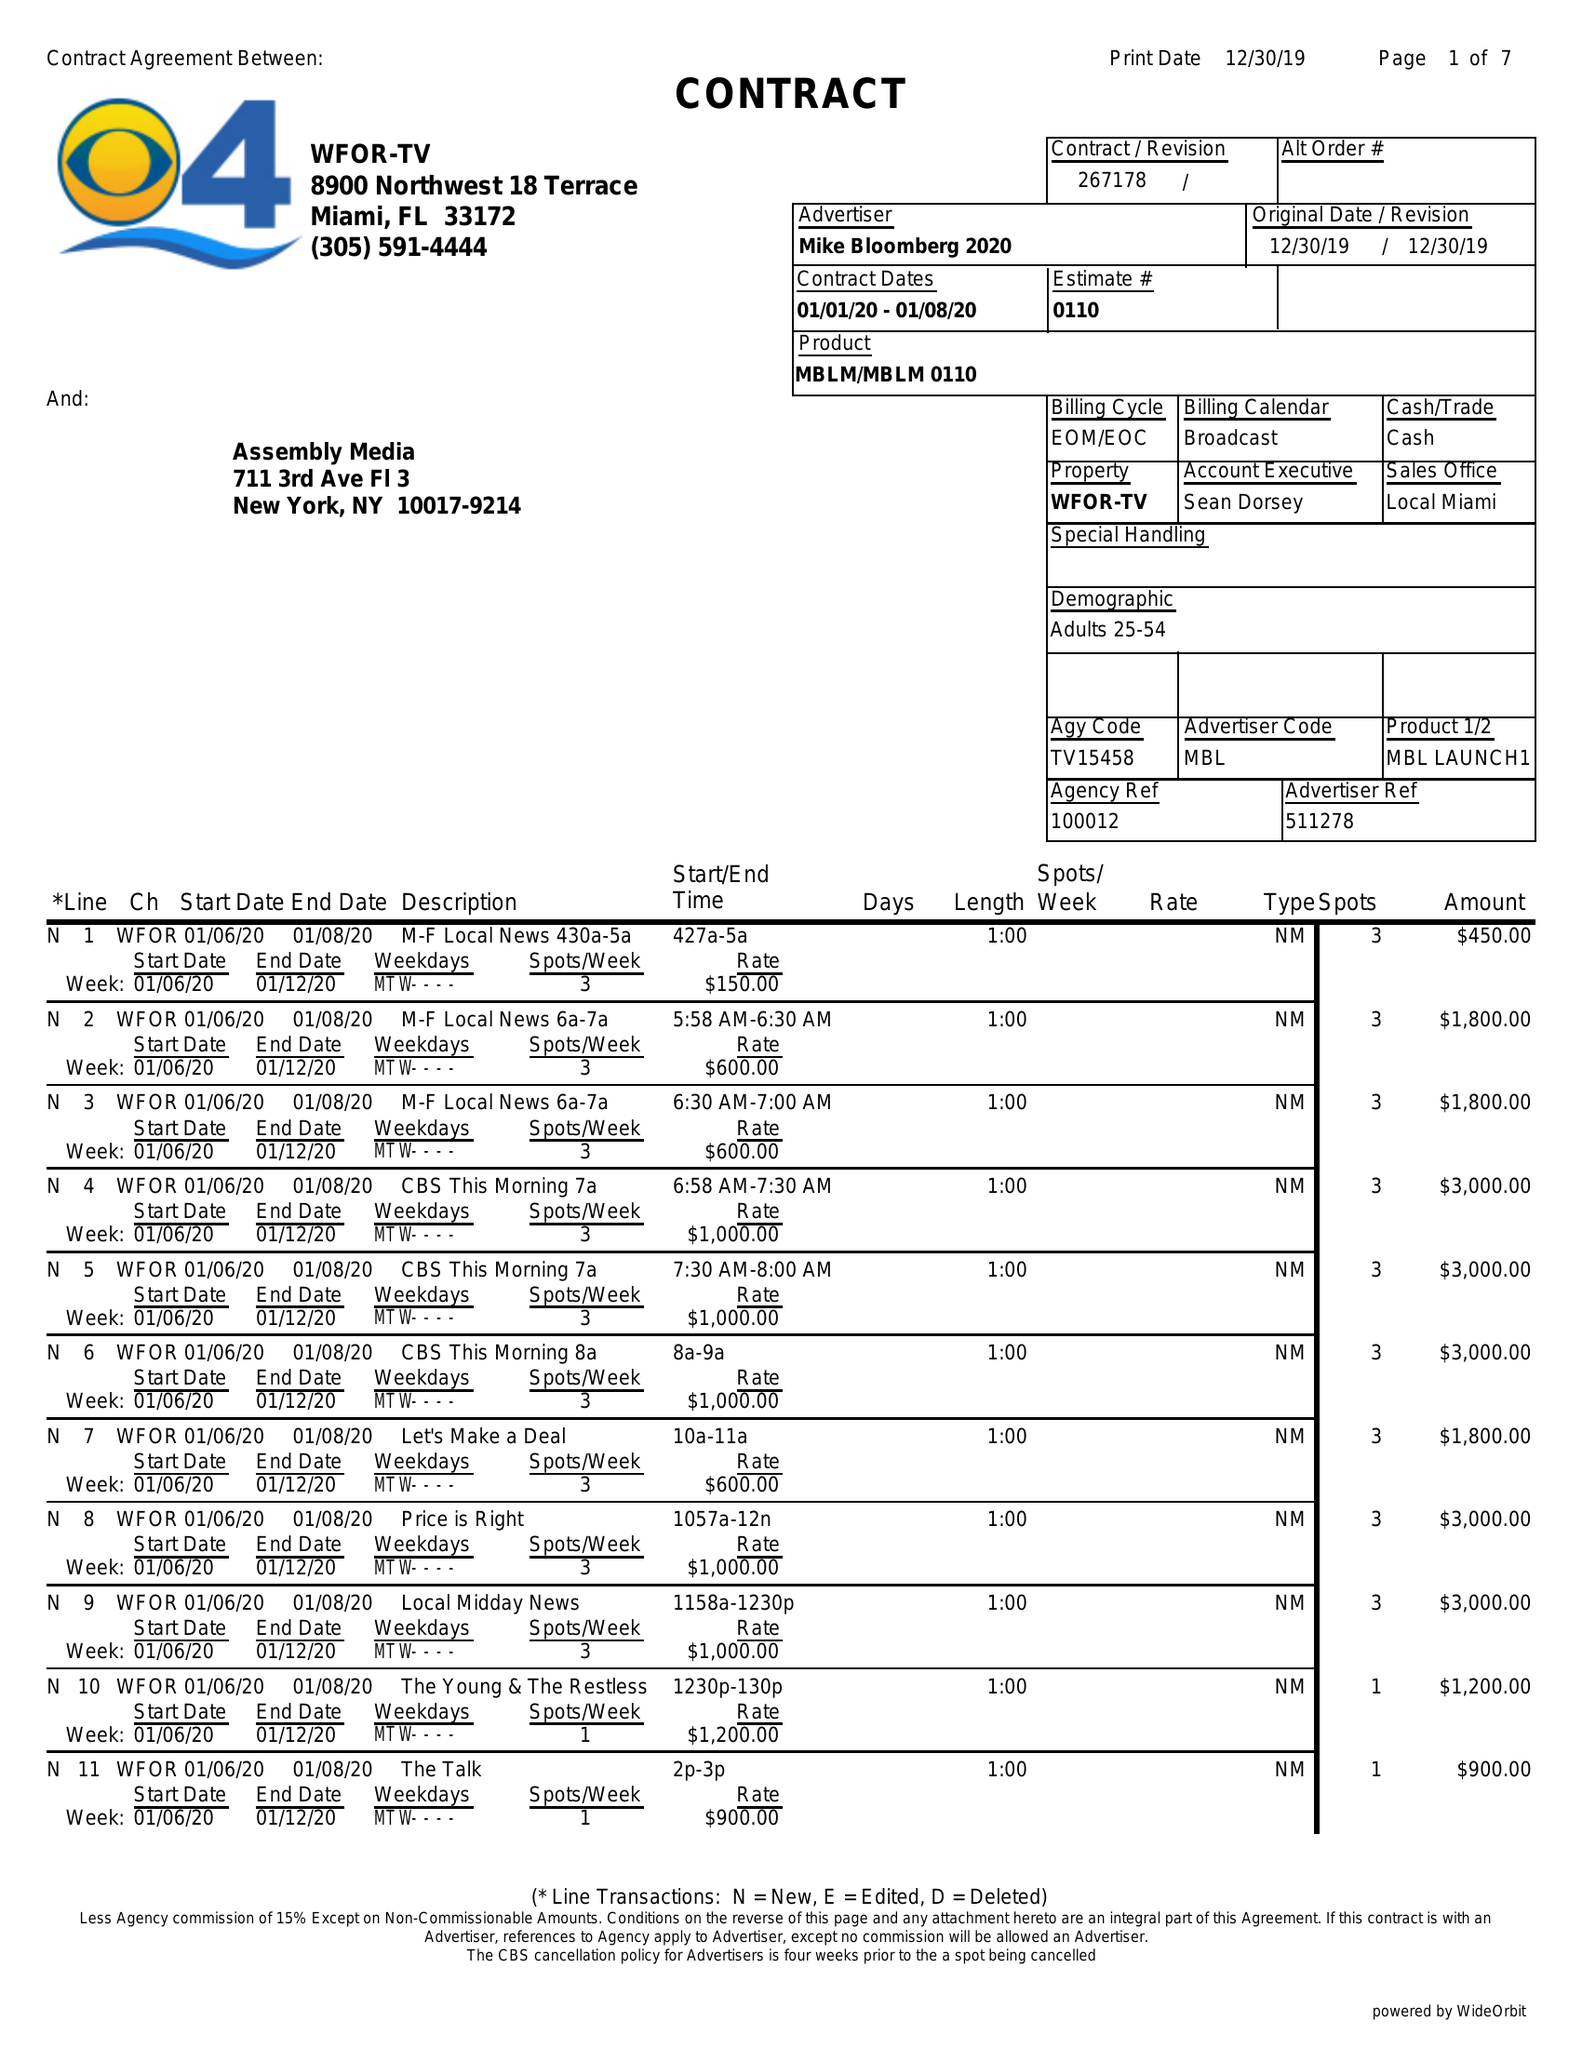What is the value for the flight_to?
Answer the question using a single word or phrase. 01/08/20 